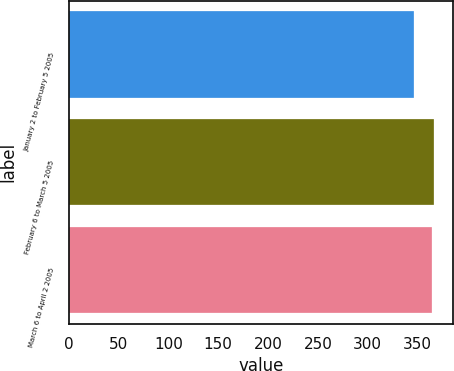<chart> <loc_0><loc_0><loc_500><loc_500><bar_chart><fcel>January 2 to February 5 2005<fcel>February 6 to March 5 2005<fcel>March 6 to April 2 2005<nl><fcel>347<fcel>367<fcel>365<nl></chart> 